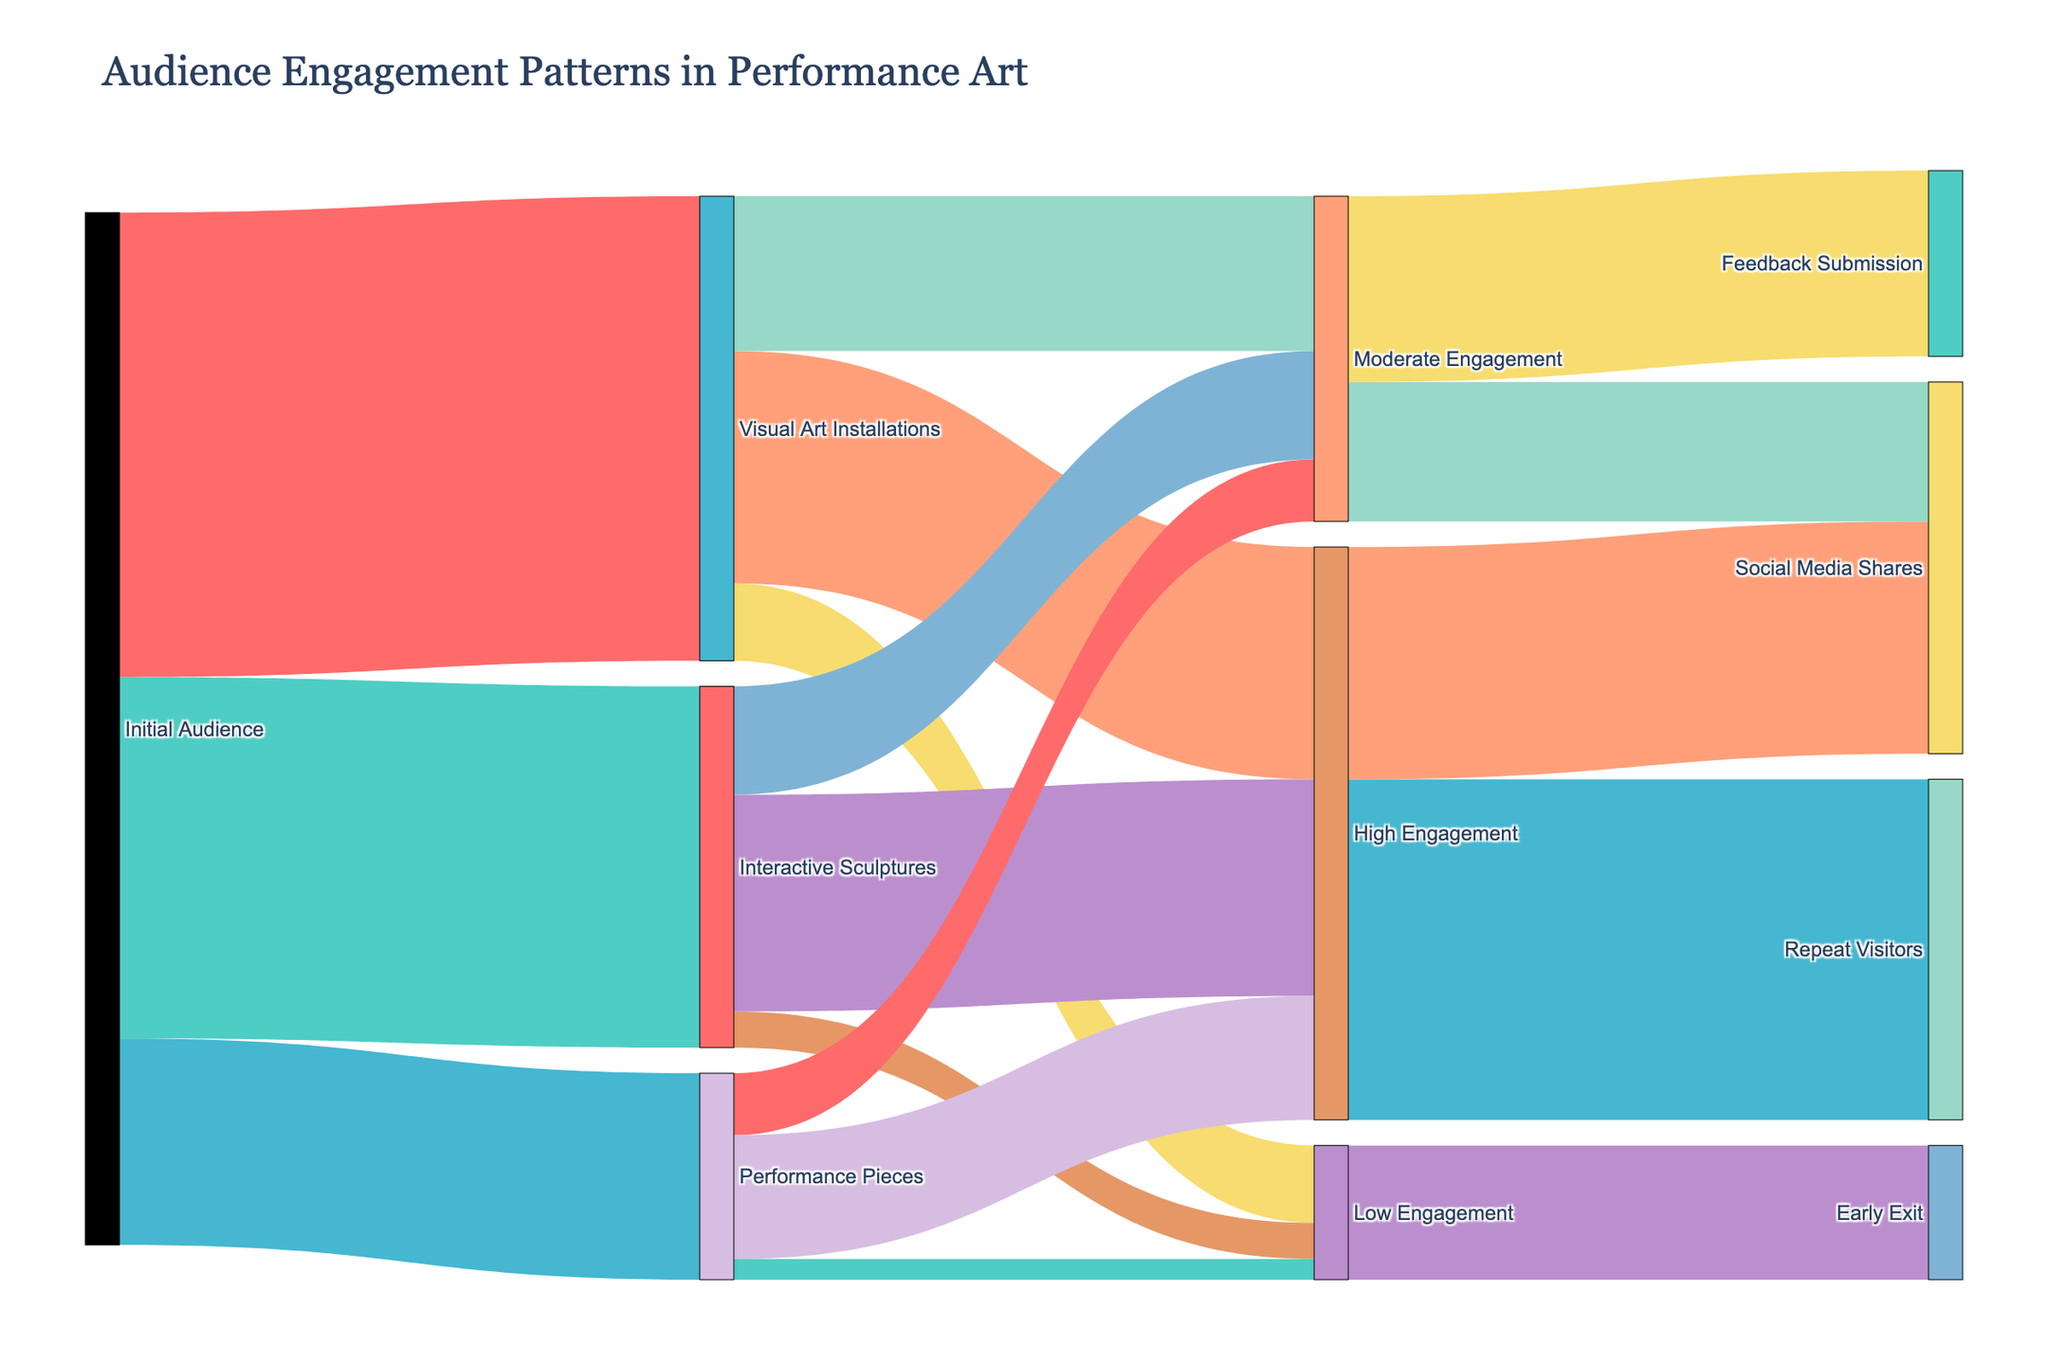What are the three main categories of audience engagement types? The three main categories of audience engagement types can be identified from the figure by examining the nodes that connect from the 'Initial Audience' node, which are 'Visual Art Installations', 'Interactive Sculptures', and 'Performance Pieces'.
Answer: Visual Art Installations, Interactive Sculptures, Performance Pieces What is the total number of audiences that started with 'Interactive Sculptures'? To find the total number of audiences that started with 'Interactive Sculptures', you just need to look at the value connecting 'Initial Audience' to 'Interactive Sculptures', which is 350.
Answer: 350 Which engagement type had the highest number of repeat visitors? To find the engagement type with the highest number of repeat visitors, follow the flows from 'High Engagement' to 'Repeat Visitors'. It connects from 'Visual Art Installations', 'Interactive Sculptures', and 'Performance Pieces'. Summing up these paths from the chart indicates that they all collectively result in 330.
Answer: High Engagement How many people showed high engagement in 'Performance Pieces'? To find this number, look at the path from 'Performance Pieces' to 'High Engagement'. The value at this connection is 120.
Answer: 120 What is the combined number of people who showed moderate engagement across all three categories? We need to sum the values connecting to 'Moderate Engagement' from all three categories: 'Visual Art Installations' (150), 'Interactive Sculptures' (105), and 'Performance Pieces' (60). The total is 150 + 105 + 60 = 315.
Answer: 315 Which category had the least high engagement? To find which category had the least high engagement, compare the values for 'High Engagement' from 'Visual Art Installations', 'Interactive Sculptures', and 'Performance Pieces'. They are 225, 210, and 120 respectively. 'Performance Pieces' has the least at 120.
Answer: Performance Pieces What is the highest engagement type flowing into 'Social Media Shares'? We need to compare the link values flowing into 'Social Media Shares'. From both 'High Engagement' (225) and 'Moderate Engagement' (135). The highest is from 'High Engagement'.
Answer: High Engagement How many audiences gave feedback from those who had moderate engagement? This can be seen by looking at the flow from 'Moderate Engagement' to 'Feedback Submission'. The value is 180.
Answer: 180 Which two engagement outcomes did all 'Low Engagement' audiences have? 'Low Engagement' audiences connect to two nodes: 'Social Media Shares' and 'Early Exit'. From the visual inspection of the chart, only 'Early Exit' is connected to 'Low Engagement', so there’s an apparent misconvey in the question analysis, primarily on 'Social Media'.
Answer: Early Exit 